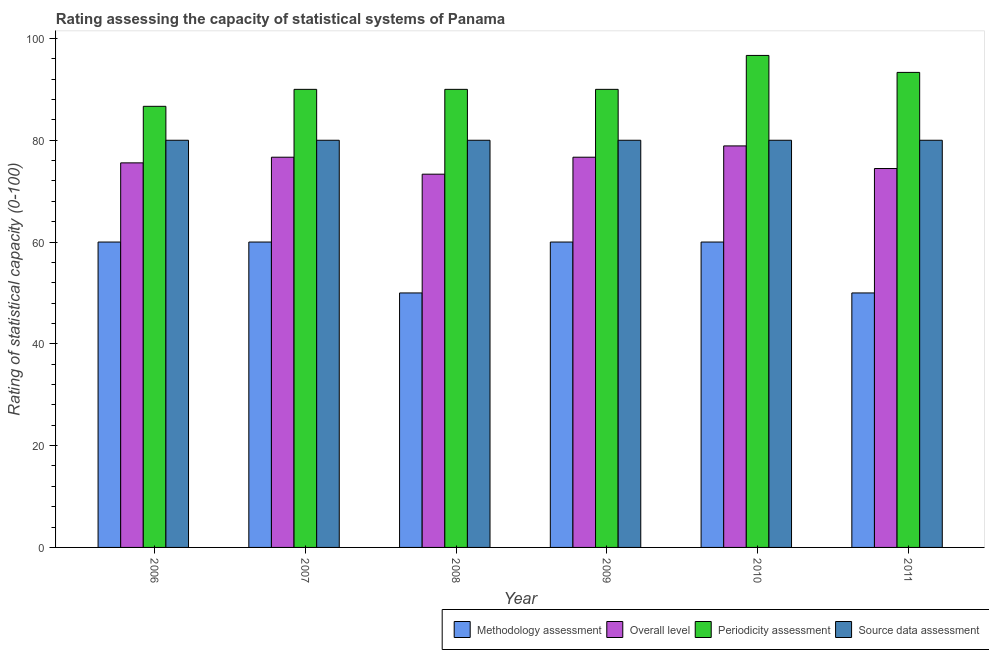How many different coloured bars are there?
Provide a short and direct response. 4. Are the number of bars per tick equal to the number of legend labels?
Your answer should be compact. Yes. Are the number of bars on each tick of the X-axis equal?
Keep it short and to the point. Yes. How many bars are there on the 4th tick from the left?
Your response must be concise. 4. What is the overall level rating in 2008?
Offer a terse response. 73.33. Across all years, what is the maximum methodology assessment rating?
Make the answer very short. 60. Across all years, what is the minimum source data assessment rating?
Your response must be concise. 80. In which year was the source data assessment rating maximum?
Your answer should be compact. 2006. In which year was the methodology assessment rating minimum?
Ensure brevity in your answer.  2008. What is the total periodicity assessment rating in the graph?
Keep it short and to the point. 546.67. What is the difference between the methodology assessment rating in 2006 and that in 2007?
Your answer should be compact. 0. What is the difference between the overall level rating in 2009 and the methodology assessment rating in 2007?
Keep it short and to the point. 0. What is the average overall level rating per year?
Ensure brevity in your answer.  75.93. In the year 2009, what is the difference between the periodicity assessment rating and methodology assessment rating?
Give a very brief answer. 0. In how many years, is the methodology assessment rating greater than 56?
Your response must be concise. 4. What is the ratio of the periodicity assessment rating in 2008 to that in 2011?
Ensure brevity in your answer.  0.96. Is the difference between the periodicity assessment rating in 2009 and 2010 greater than the difference between the source data assessment rating in 2009 and 2010?
Give a very brief answer. No. What is the difference between the highest and the second highest overall level rating?
Keep it short and to the point. 2.22. In how many years, is the periodicity assessment rating greater than the average periodicity assessment rating taken over all years?
Ensure brevity in your answer.  2. What does the 4th bar from the left in 2007 represents?
Your response must be concise. Source data assessment. What does the 2nd bar from the right in 2007 represents?
Provide a succinct answer. Periodicity assessment. How many bars are there?
Ensure brevity in your answer.  24. Are all the bars in the graph horizontal?
Make the answer very short. No. How many years are there in the graph?
Provide a short and direct response. 6. What is the difference between two consecutive major ticks on the Y-axis?
Ensure brevity in your answer.  20. Does the graph contain any zero values?
Your answer should be very brief. No. Does the graph contain grids?
Make the answer very short. No. How many legend labels are there?
Ensure brevity in your answer.  4. What is the title of the graph?
Your answer should be very brief. Rating assessing the capacity of statistical systems of Panama. What is the label or title of the Y-axis?
Ensure brevity in your answer.  Rating of statistical capacity (0-100). What is the Rating of statistical capacity (0-100) in Methodology assessment in 2006?
Ensure brevity in your answer.  60. What is the Rating of statistical capacity (0-100) in Overall level in 2006?
Your answer should be compact. 75.56. What is the Rating of statistical capacity (0-100) of Periodicity assessment in 2006?
Ensure brevity in your answer.  86.67. What is the Rating of statistical capacity (0-100) of Overall level in 2007?
Provide a succinct answer. 76.67. What is the Rating of statistical capacity (0-100) of Methodology assessment in 2008?
Ensure brevity in your answer.  50. What is the Rating of statistical capacity (0-100) of Overall level in 2008?
Ensure brevity in your answer.  73.33. What is the Rating of statistical capacity (0-100) in Periodicity assessment in 2008?
Make the answer very short. 90. What is the Rating of statistical capacity (0-100) of Methodology assessment in 2009?
Offer a very short reply. 60. What is the Rating of statistical capacity (0-100) of Overall level in 2009?
Provide a short and direct response. 76.67. What is the Rating of statistical capacity (0-100) of Periodicity assessment in 2009?
Your response must be concise. 90. What is the Rating of statistical capacity (0-100) in Overall level in 2010?
Give a very brief answer. 78.89. What is the Rating of statistical capacity (0-100) of Periodicity assessment in 2010?
Ensure brevity in your answer.  96.67. What is the Rating of statistical capacity (0-100) in Methodology assessment in 2011?
Make the answer very short. 50. What is the Rating of statistical capacity (0-100) of Overall level in 2011?
Offer a very short reply. 74.44. What is the Rating of statistical capacity (0-100) in Periodicity assessment in 2011?
Your answer should be very brief. 93.33. What is the Rating of statistical capacity (0-100) of Source data assessment in 2011?
Your answer should be very brief. 80. Across all years, what is the maximum Rating of statistical capacity (0-100) in Overall level?
Provide a succinct answer. 78.89. Across all years, what is the maximum Rating of statistical capacity (0-100) in Periodicity assessment?
Your answer should be very brief. 96.67. Across all years, what is the minimum Rating of statistical capacity (0-100) of Methodology assessment?
Provide a succinct answer. 50. Across all years, what is the minimum Rating of statistical capacity (0-100) of Overall level?
Offer a very short reply. 73.33. Across all years, what is the minimum Rating of statistical capacity (0-100) of Periodicity assessment?
Your answer should be compact. 86.67. Across all years, what is the minimum Rating of statistical capacity (0-100) in Source data assessment?
Provide a succinct answer. 80. What is the total Rating of statistical capacity (0-100) of Methodology assessment in the graph?
Your response must be concise. 340. What is the total Rating of statistical capacity (0-100) of Overall level in the graph?
Offer a terse response. 455.56. What is the total Rating of statistical capacity (0-100) of Periodicity assessment in the graph?
Offer a very short reply. 546.67. What is the total Rating of statistical capacity (0-100) of Source data assessment in the graph?
Your answer should be compact. 480. What is the difference between the Rating of statistical capacity (0-100) in Methodology assessment in 2006 and that in 2007?
Keep it short and to the point. 0. What is the difference between the Rating of statistical capacity (0-100) of Overall level in 2006 and that in 2007?
Provide a succinct answer. -1.11. What is the difference between the Rating of statistical capacity (0-100) in Periodicity assessment in 2006 and that in 2007?
Provide a succinct answer. -3.33. What is the difference between the Rating of statistical capacity (0-100) in Source data assessment in 2006 and that in 2007?
Keep it short and to the point. 0. What is the difference between the Rating of statistical capacity (0-100) in Methodology assessment in 2006 and that in 2008?
Give a very brief answer. 10. What is the difference between the Rating of statistical capacity (0-100) in Overall level in 2006 and that in 2008?
Provide a short and direct response. 2.22. What is the difference between the Rating of statistical capacity (0-100) in Periodicity assessment in 2006 and that in 2008?
Offer a very short reply. -3.33. What is the difference between the Rating of statistical capacity (0-100) in Methodology assessment in 2006 and that in 2009?
Provide a short and direct response. 0. What is the difference between the Rating of statistical capacity (0-100) in Overall level in 2006 and that in 2009?
Your response must be concise. -1.11. What is the difference between the Rating of statistical capacity (0-100) of Periodicity assessment in 2006 and that in 2009?
Keep it short and to the point. -3.33. What is the difference between the Rating of statistical capacity (0-100) in Methodology assessment in 2006 and that in 2010?
Ensure brevity in your answer.  0. What is the difference between the Rating of statistical capacity (0-100) in Overall level in 2006 and that in 2010?
Make the answer very short. -3.33. What is the difference between the Rating of statistical capacity (0-100) in Source data assessment in 2006 and that in 2010?
Provide a short and direct response. 0. What is the difference between the Rating of statistical capacity (0-100) of Overall level in 2006 and that in 2011?
Give a very brief answer. 1.11. What is the difference between the Rating of statistical capacity (0-100) of Periodicity assessment in 2006 and that in 2011?
Provide a short and direct response. -6.67. What is the difference between the Rating of statistical capacity (0-100) in Source data assessment in 2006 and that in 2011?
Offer a terse response. 0. What is the difference between the Rating of statistical capacity (0-100) of Periodicity assessment in 2007 and that in 2008?
Provide a succinct answer. 0. What is the difference between the Rating of statistical capacity (0-100) of Overall level in 2007 and that in 2009?
Offer a terse response. 0. What is the difference between the Rating of statistical capacity (0-100) in Methodology assessment in 2007 and that in 2010?
Offer a very short reply. 0. What is the difference between the Rating of statistical capacity (0-100) of Overall level in 2007 and that in 2010?
Your answer should be compact. -2.22. What is the difference between the Rating of statistical capacity (0-100) in Periodicity assessment in 2007 and that in 2010?
Keep it short and to the point. -6.67. What is the difference between the Rating of statistical capacity (0-100) of Overall level in 2007 and that in 2011?
Your answer should be very brief. 2.22. What is the difference between the Rating of statistical capacity (0-100) in Periodicity assessment in 2007 and that in 2011?
Offer a very short reply. -3.33. What is the difference between the Rating of statistical capacity (0-100) in Source data assessment in 2007 and that in 2011?
Provide a succinct answer. 0. What is the difference between the Rating of statistical capacity (0-100) of Methodology assessment in 2008 and that in 2009?
Your response must be concise. -10. What is the difference between the Rating of statistical capacity (0-100) of Periodicity assessment in 2008 and that in 2009?
Ensure brevity in your answer.  0. What is the difference between the Rating of statistical capacity (0-100) of Methodology assessment in 2008 and that in 2010?
Your answer should be compact. -10. What is the difference between the Rating of statistical capacity (0-100) in Overall level in 2008 and that in 2010?
Ensure brevity in your answer.  -5.56. What is the difference between the Rating of statistical capacity (0-100) in Periodicity assessment in 2008 and that in 2010?
Your answer should be very brief. -6.67. What is the difference between the Rating of statistical capacity (0-100) in Source data assessment in 2008 and that in 2010?
Keep it short and to the point. 0. What is the difference between the Rating of statistical capacity (0-100) in Methodology assessment in 2008 and that in 2011?
Your answer should be very brief. 0. What is the difference between the Rating of statistical capacity (0-100) of Overall level in 2008 and that in 2011?
Give a very brief answer. -1.11. What is the difference between the Rating of statistical capacity (0-100) of Periodicity assessment in 2008 and that in 2011?
Provide a short and direct response. -3.33. What is the difference between the Rating of statistical capacity (0-100) in Methodology assessment in 2009 and that in 2010?
Make the answer very short. 0. What is the difference between the Rating of statistical capacity (0-100) in Overall level in 2009 and that in 2010?
Ensure brevity in your answer.  -2.22. What is the difference between the Rating of statistical capacity (0-100) of Periodicity assessment in 2009 and that in 2010?
Give a very brief answer. -6.67. What is the difference between the Rating of statistical capacity (0-100) in Source data assessment in 2009 and that in 2010?
Offer a terse response. 0. What is the difference between the Rating of statistical capacity (0-100) of Overall level in 2009 and that in 2011?
Your answer should be very brief. 2.22. What is the difference between the Rating of statistical capacity (0-100) of Source data assessment in 2009 and that in 2011?
Your answer should be compact. 0. What is the difference between the Rating of statistical capacity (0-100) of Methodology assessment in 2010 and that in 2011?
Give a very brief answer. 10. What is the difference between the Rating of statistical capacity (0-100) of Overall level in 2010 and that in 2011?
Offer a terse response. 4.44. What is the difference between the Rating of statistical capacity (0-100) in Methodology assessment in 2006 and the Rating of statistical capacity (0-100) in Overall level in 2007?
Your answer should be very brief. -16.67. What is the difference between the Rating of statistical capacity (0-100) in Methodology assessment in 2006 and the Rating of statistical capacity (0-100) in Periodicity assessment in 2007?
Offer a terse response. -30. What is the difference between the Rating of statistical capacity (0-100) in Methodology assessment in 2006 and the Rating of statistical capacity (0-100) in Source data assessment in 2007?
Offer a very short reply. -20. What is the difference between the Rating of statistical capacity (0-100) of Overall level in 2006 and the Rating of statistical capacity (0-100) of Periodicity assessment in 2007?
Provide a short and direct response. -14.44. What is the difference between the Rating of statistical capacity (0-100) in Overall level in 2006 and the Rating of statistical capacity (0-100) in Source data assessment in 2007?
Offer a very short reply. -4.44. What is the difference between the Rating of statistical capacity (0-100) in Methodology assessment in 2006 and the Rating of statistical capacity (0-100) in Overall level in 2008?
Your answer should be compact. -13.33. What is the difference between the Rating of statistical capacity (0-100) in Methodology assessment in 2006 and the Rating of statistical capacity (0-100) in Periodicity assessment in 2008?
Make the answer very short. -30. What is the difference between the Rating of statistical capacity (0-100) of Methodology assessment in 2006 and the Rating of statistical capacity (0-100) of Source data assessment in 2008?
Keep it short and to the point. -20. What is the difference between the Rating of statistical capacity (0-100) in Overall level in 2006 and the Rating of statistical capacity (0-100) in Periodicity assessment in 2008?
Your answer should be compact. -14.44. What is the difference between the Rating of statistical capacity (0-100) of Overall level in 2006 and the Rating of statistical capacity (0-100) of Source data assessment in 2008?
Your response must be concise. -4.44. What is the difference between the Rating of statistical capacity (0-100) in Periodicity assessment in 2006 and the Rating of statistical capacity (0-100) in Source data assessment in 2008?
Offer a terse response. 6.67. What is the difference between the Rating of statistical capacity (0-100) in Methodology assessment in 2006 and the Rating of statistical capacity (0-100) in Overall level in 2009?
Make the answer very short. -16.67. What is the difference between the Rating of statistical capacity (0-100) in Methodology assessment in 2006 and the Rating of statistical capacity (0-100) in Source data assessment in 2009?
Provide a succinct answer. -20. What is the difference between the Rating of statistical capacity (0-100) of Overall level in 2006 and the Rating of statistical capacity (0-100) of Periodicity assessment in 2009?
Ensure brevity in your answer.  -14.44. What is the difference between the Rating of statistical capacity (0-100) of Overall level in 2006 and the Rating of statistical capacity (0-100) of Source data assessment in 2009?
Your answer should be very brief. -4.44. What is the difference between the Rating of statistical capacity (0-100) of Periodicity assessment in 2006 and the Rating of statistical capacity (0-100) of Source data assessment in 2009?
Provide a succinct answer. 6.67. What is the difference between the Rating of statistical capacity (0-100) in Methodology assessment in 2006 and the Rating of statistical capacity (0-100) in Overall level in 2010?
Your response must be concise. -18.89. What is the difference between the Rating of statistical capacity (0-100) in Methodology assessment in 2006 and the Rating of statistical capacity (0-100) in Periodicity assessment in 2010?
Provide a succinct answer. -36.67. What is the difference between the Rating of statistical capacity (0-100) of Methodology assessment in 2006 and the Rating of statistical capacity (0-100) of Source data assessment in 2010?
Provide a succinct answer. -20. What is the difference between the Rating of statistical capacity (0-100) in Overall level in 2006 and the Rating of statistical capacity (0-100) in Periodicity assessment in 2010?
Ensure brevity in your answer.  -21.11. What is the difference between the Rating of statistical capacity (0-100) of Overall level in 2006 and the Rating of statistical capacity (0-100) of Source data assessment in 2010?
Provide a short and direct response. -4.44. What is the difference between the Rating of statistical capacity (0-100) of Methodology assessment in 2006 and the Rating of statistical capacity (0-100) of Overall level in 2011?
Give a very brief answer. -14.44. What is the difference between the Rating of statistical capacity (0-100) of Methodology assessment in 2006 and the Rating of statistical capacity (0-100) of Periodicity assessment in 2011?
Offer a terse response. -33.33. What is the difference between the Rating of statistical capacity (0-100) in Methodology assessment in 2006 and the Rating of statistical capacity (0-100) in Source data assessment in 2011?
Provide a succinct answer. -20. What is the difference between the Rating of statistical capacity (0-100) in Overall level in 2006 and the Rating of statistical capacity (0-100) in Periodicity assessment in 2011?
Offer a very short reply. -17.78. What is the difference between the Rating of statistical capacity (0-100) in Overall level in 2006 and the Rating of statistical capacity (0-100) in Source data assessment in 2011?
Your answer should be compact. -4.44. What is the difference between the Rating of statistical capacity (0-100) in Methodology assessment in 2007 and the Rating of statistical capacity (0-100) in Overall level in 2008?
Ensure brevity in your answer.  -13.33. What is the difference between the Rating of statistical capacity (0-100) in Methodology assessment in 2007 and the Rating of statistical capacity (0-100) in Periodicity assessment in 2008?
Provide a short and direct response. -30. What is the difference between the Rating of statistical capacity (0-100) of Methodology assessment in 2007 and the Rating of statistical capacity (0-100) of Source data assessment in 2008?
Your answer should be very brief. -20. What is the difference between the Rating of statistical capacity (0-100) in Overall level in 2007 and the Rating of statistical capacity (0-100) in Periodicity assessment in 2008?
Your answer should be compact. -13.33. What is the difference between the Rating of statistical capacity (0-100) of Overall level in 2007 and the Rating of statistical capacity (0-100) of Source data assessment in 2008?
Keep it short and to the point. -3.33. What is the difference between the Rating of statistical capacity (0-100) in Methodology assessment in 2007 and the Rating of statistical capacity (0-100) in Overall level in 2009?
Offer a very short reply. -16.67. What is the difference between the Rating of statistical capacity (0-100) of Methodology assessment in 2007 and the Rating of statistical capacity (0-100) of Source data assessment in 2009?
Give a very brief answer. -20. What is the difference between the Rating of statistical capacity (0-100) in Overall level in 2007 and the Rating of statistical capacity (0-100) in Periodicity assessment in 2009?
Offer a very short reply. -13.33. What is the difference between the Rating of statistical capacity (0-100) in Overall level in 2007 and the Rating of statistical capacity (0-100) in Source data assessment in 2009?
Ensure brevity in your answer.  -3.33. What is the difference between the Rating of statistical capacity (0-100) in Periodicity assessment in 2007 and the Rating of statistical capacity (0-100) in Source data assessment in 2009?
Offer a terse response. 10. What is the difference between the Rating of statistical capacity (0-100) of Methodology assessment in 2007 and the Rating of statistical capacity (0-100) of Overall level in 2010?
Make the answer very short. -18.89. What is the difference between the Rating of statistical capacity (0-100) of Methodology assessment in 2007 and the Rating of statistical capacity (0-100) of Periodicity assessment in 2010?
Give a very brief answer. -36.67. What is the difference between the Rating of statistical capacity (0-100) in Overall level in 2007 and the Rating of statistical capacity (0-100) in Periodicity assessment in 2010?
Ensure brevity in your answer.  -20. What is the difference between the Rating of statistical capacity (0-100) of Methodology assessment in 2007 and the Rating of statistical capacity (0-100) of Overall level in 2011?
Ensure brevity in your answer.  -14.44. What is the difference between the Rating of statistical capacity (0-100) in Methodology assessment in 2007 and the Rating of statistical capacity (0-100) in Periodicity assessment in 2011?
Provide a short and direct response. -33.33. What is the difference between the Rating of statistical capacity (0-100) in Overall level in 2007 and the Rating of statistical capacity (0-100) in Periodicity assessment in 2011?
Offer a terse response. -16.67. What is the difference between the Rating of statistical capacity (0-100) of Periodicity assessment in 2007 and the Rating of statistical capacity (0-100) of Source data assessment in 2011?
Your response must be concise. 10. What is the difference between the Rating of statistical capacity (0-100) in Methodology assessment in 2008 and the Rating of statistical capacity (0-100) in Overall level in 2009?
Offer a very short reply. -26.67. What is the difference between the Rating of statistical capacity (0-100) in Overall level in 2008 and the Rating of statistical capacity (0-100) in Periodicity assessment in 2009?
Offer a terse response. -16.67. What is the difference between the Rating of statistical capacity (0-100) in Overall level in 2008 and the Rating of statistical capacity (0-100) in Source data assessment in 2009?
Your answer should be compact. -6.67. What is the difference between the Rating of statistical capacity (0-100) of Methodology assessment in 2008 and the Rating of statistical capacity (0-100) of Overall level in 2010?
Make the answer very short. -28.89. What is the difference between the Rating of statistical capacity (0-100) in Methodology assessment in 2008 and the Rating of statistical capacity (0-100) in Periodicity assessment in 2010?
Your answer should be compact. -46.67. What is the difference between the Rating of statistical capacity (0-100) in Methodology assessment in 2008 and the Rating of statistical capacity (0-100) in Source data assessment in 2010?
Make the answer very short. -30. What is the difference between the Rating of statistical capacity (0-100) of Overall level in 2008 and the Rating of statistical capacity (0-100) of Periodicity assessment in 2010?
Make the answer very short. -23.33. What is the difference between the Rating of statistical capacity (0-100) in Overall level in 2008 and the Rating of statistical capacity (0-100) in Source data assessment in 2010?
Your answer should be very brief. -6.67. What is the difference between the Rating of statistical capacity (0-100) in Periodicity assessment in 2008 and the Rating of statistical capacity (0-100) in Source data assessment in 2010?
Make the answer very short. 10. What is the difference between the Rating of statistical capacity (0-100) of Methodology assessment in 2008 and the Rating of statistical capacity (0-100) of Overall level in 2011?
Ensure brevity in your answer.  -24.44. What is the difference between the Rating of statistical capacity (0-100) in Methodology assessment in 2008 and the Rating of statistical capacity (0-100) in Periodicity assessment in 2011?
Your answer should be compact. -43.33. What is the difference between the Rating of statistical capacity (0-100) in Overall level in 2008 and the Rating of statistical capacity (0-100) in Source data assessment in 2011?
Give a very brief answer. -6.67. What is the difference between the Rating of statistical capacity (0-100) in Periodicity assessment in 2008 and the Rating of statistical capacity (0-100) in Source data assessment in 2011?
Make the answer very short. 10. What is the difference between the Rating of statistical capacity (0-100) of Methodology assessment in 2009 and the Rating of statistical capacity (0-100) of Overall level in 2010?
Your answer should be very brief. -18.89. What is the difference between the Rating of statistical capacity (0-100) of Methodology assessment in 2009 and the Rating of statistical capacity (0-100) of Periodicity assessment in 2010?
Provide a short and direct response. -36.67. What is the difference between the Rating of statistical capacity (0-100) of Methodology assessment in 2009 and the Rating of statistical capacity (0-100) of Source data assessment in 2010?
Your answer should be very brief. -20. What is the difference between the Rating of statistical capacity (0-100) in Periodicity assessment in 2009 and the Rating of statistical capacity (0-100) in Source data assessment in 2010?
Your answer should be very brief. 10. What is the difference between the Rating of statistical capacity (0-100) in Methodology assessment in 2009 and the Rating of statistical capacity (0-100) in Overall level in 2011?
Offer a very short reply. -14.44. What is the difference between the Rating of statistical capacity (0-100) of Methodology assessment in 2009 and the Rating of statistical capacity (0-100) of Periodicity assessment in 2011?
Offer a very short reply. -33.33. What is the difference between the Rating of statistical capacity (0-100) in Methodology assessment in 2009 and the Rating of statistical capacity (0-100) in Source data assessment in 2011?
Ensure brevity in your answer.  -20. What is the difference between the Rating of statistical capacity (0-100) of Overall level in 2009 and the Rating of statistical capacity (0-100) of Periodicity assessment in 2011?
Your response must be concise. -16.67. What is the difference between the Rating of statistical capacity (0-100) of Overall level in 2009 and the Rating of statistical capacity (0-100) of Source data assessment in 2011?
Offer a terse response. -3.33. What is the difference between the Rating of statistical capacity (0-100) in Methodology assessment in 2010 and the Rating of statistical capacity (0-100) in Overall level in 2011?
Your answer should be very brief. -14.44. What is the difference between the Rating of statistical capacity (0-100) in Methodology assessment in 2010 and the Rating of statistical capacity (0-100) in Periodicity assessment in 2011?
Provide a short and direct response. -33.33. What is the difference between the Rating of statistical capacity (0-100) in Overall level in 2010 and the Rating of statistical capacity (0-100) in Periodicity assessment in 2011?
Offer a very short reply. -14.44. What is the difference between the Rating of statistical capacity (0-100) in Overall level in 2010 and the Rating of statistical capacity (0-100) in Source data assessment in 2011?
Make the answer very short. -1.11. What is the difference between the Rating of statistical capacity (0-100) of Periodicity assessment in 2010 and the Rating of statistical capacity (0-100) of Source data assessment in 2011?
Ensure brevity in your answer.  16.67. What is the average Rating of statistical capacity (0-100) of Methodology assessment per year?
Keep it short and to the point. 56.67. What is the average Rating of statistical capacity (0-100) of Overall level per year?
Keep it short and to the point. 75.93. What is the average Rating of statistical capacity (0-100) in Periodicity assessment per year?
Keep it short and to the point. 91.11. What is the average Rating of statistical capacity (0-100) in Source data assessment per year?
Your answer should be compact. 80. In the year 2006, what is the difference between the Rating of statistical capacity (0-100) of Methodology assessment and Rating of statistical capacity (0-100) of Overall level?
Make the answer very short. -15.56. In the year 2006, what is the difference between the Rating of statistical capacity (0-100) in Methodology assessment and Rating of statistical capacity (0-100) in Periodicity assessment?
Your answer should be compact. -26.67. In the year 2006, what is the difference between the Rating of statistical capacity (0-100) of Methodology assessment and Rating of statistical capacity (0-100) of Source data assessment?
Make the answer very short. -20. In the year 2006, what is the difference between the Rating of statistical capacity (0-100) of Overall level and Rating of statistical capacity (0-100) of Periodicity assessment?
Ensure brevity in your answer.  -11.11. In the year 2006, what is the difference between the Rating of statistical capacity (0-100) of Overall level and Rating of statistical capacity (0-100) of Source data assessment?
Keep it short and to the point. -4.44. In the year 2006, what is the difference between the Rating of statistical capacity (0-100) of Periodicity assessment and Rating of statistical capacity (0-100) of Source data assessment?
Make the answer very short. 6.67. In the year 2007, what is the difference between the Rating of statistical capacity (0-100) of Methodology assessment and Rating of statistical capacity (0-100) of Overall level?
Offer a very short reply. -16.67. In the year 2007, what is the difference between the Rating of statistical capacity (0-100) of Overall level and Rating of statistical capacity (0-100) of Periodicity assessment?
Provide a short and direct response. -13.33. In the year 2007, what is the difference between the Rating of statistical capacity (0-100) of Periodicity assessment and Rating of statistical capacity (0-100) of Source data assessment?
Your response must be concise. 10. In the year 2008, what is the difference between the Rating of statistical capacity (0-100) of Methodology assessment and Rating of statistical capacity (0-100) of Overall level?
Make the answer very short. -23.33. In the year 2008, what is the difference between the Rating of statistical capacity (0-100) in Overall level and Rating of statistical capacity (0-100) in Periodicity assessment?
Your response must be concise. -16.67. In the year 2008, what is the difference between the Rating of statistical capacity (0-100) of Overall level and Rating of statistical capacity (0-100) of Source data assessment?
Provide a short and direct response. -6.67. In the year 2008, what is the difference between the Rating of statistical capacity (0-100) in Periodicity assessment and Rating of statistical capacity (0-100) in Source data assessment?
Keep it short and to the point. 10. In the year 2009, what is the difference between the Rating of statistical capacity (0-100) in Methodology assessment and Rating of statistical capacity (0-100) in Overall level?
Give a very brief answer. -16.67. In the year 2009, what is the difference between the Rating of statistical capacity (0-100) of Methodology assessment and Rating of statistical capacity (0-100) of Periodicity assessment?
Your answer should be very brief. -30. In the year 2009, what is the difference between the Rating of statistical capacity (0-100) in Overall level and Rating of statistical capacity (0-100) in Periodicity assessment?
Keep it short and to the point. -13.33. In the year 2009, what is the difference between the Rating of statistical capacity (0-100) of Overall level and Rating of statistical capacity (0-100) of Source data assessment?
Provide a succinct answer. -3.33. In the year 2009, what is the difference between the Rating of statistical capacity (0-100) in Periodicity assessment and Rating of statistical capacity (0-100) in Source data assessment?
Ensure brevity in your answer.  10. In the year 2010, what is the difference between the Rating of statistical capacity (0-100) of Methodology assessment and Rating of statistical capacity (0-100) of Overall level?
Ensure brevity in your answer.  -18.89. In the year 2010, what is the difference between the Rating of statistical capacity (0-100) in Methodology assessment and Rating of statistical capacity (0-100) in Periodicity assessment?
Offer a very short reply. -36.67. In the year 2010, what is the difference between the Rating of statistical capacity (0-100) in Overall level and Rating of statistical capacity (0-100) in Periodicity assessment?
Your answer should be compact. -17.78. In the year 2010, what is the difference between the Rating of statistical capacity (0-100) in Overall level and Rating of statistical capacity (0-100) in Source data assessment?
Make the answer very short. -1.11. In the year 2010, what is the difference between the Rating of statistical capacity (0-100) of Periodicity assessment and Rating of statistical capacity (0-100) of Source data assessment?
Your answer should be compact. 16.67. In the year 2011, what is the difference between the Rating of statistical capacity (0-100) of Methodology assessment and Rating of statistical capacity (0-100) of Overall level?
Offer a terse response. -24.44. In the year 2011, what is the difference between the Rating of statistical capacity (0-100) of Methodology assessment and Rating of statistical capacity (0-100) of Periodicity assessment?
Keep it short and to the point. -43.33. In the year 2011, what is the difference between the Rating of statistical capacity (0-100) of Overall level and Rating of statistical capacity (0-100) of Periodicity assessment?
Provide a succinct answer. -18.89. In the year 2011, what is the difference between the Rating of statistical capacity (0-100) in Overall level and Rating of statistical capacity (0-100) in Source data assessment?
Keep it short and to the point. -5.56. In the year 2011, what is the difference between the Rating of statistical capacity (0-100) of Periodicity assessment and Rating of statistical capacity (0-100) of Source data assessment?
Provide a short and direct response. 13.33. What is the ratio of the Rating of statistical capacity (0-100) in Methodology assessment in 2006 to that in 2007?
Offer a terse response. 1. What is the ratio of the Rating of statistical capacity (0-100) of Overall level in 2006 to that in 2007?
Make the answer very short. 0.99. What is the ratio of the Rating of statistical capacity (0-100) in Overall level in 2006 to that in 2008?
Provide a short and direct response. 1.03. What is the ratio of the Rating of statistical capacity (0-100) of Overall level in 2006 to that in 2009?
Offer a very short reply. 0.99. What is the ratio of the Rating of statistical capacity (0-100) of Source data assessment in 2006 to that in 2009?
Ensure brevity in your answer.  1. What is the ratio of the Rating of statistical capacity (0-100) of Methodology assessment in 2006 to that in 2010?
Provide a succinct answer. 1. What is the ratio of the Rating of statistical capacity (0-100) in Overall level in 2006 to that in 2010?
Ensure brevity in your answer.  0.96. What is the ratio of the Rating of statistical capacity (0-100) of Periodicity assessment in 2006 to that in 2010?
Provide a succinct answer. 0.9. What is the ratio of the Rating of statistical capacity (0-100) in Source data assessment in 2006 to that in 2010?
Your answer should be compact. 1. What is the ratio of the Rating of statistical capacity (0-100) of Overall level in 2006 to that in 2011?
Your answer should be compact. 1.01. What is the ratio of the Rating of statistical capacity (0-100) in Source data assessment in 2006 to that in 2011?
Your answer should be compact. 1. What is the ratio of the Rating of statistical capacity (0-100) in Methodology assessment in 2007 to that in 2008?
Offer a very short reply. 1.2. What is the ratio of the Rating of statistical capacity (0-100) of Overall level in 2007 to that in 2008?
Your response must be concise. 1.05. What is the ratio of the Rating of statistical capacity (0-100) of Periodicity assessment in 2007 to that in 2008?
Make the answer very short. 1. What is the ratio of the Rating of statistical capacity (0-100) in Methodology assessment in 2007 to that in 2009?
Keep it short and to the point. 1. What is the ratio of the Rating of statistical capacity (0-100) in Periodicity assessment in 2007 to that in 2009?
Ensure brevity in your answer.  1. What is the ratio of the Rating of statistical capacity (0-100) in Overall level in 2007 to that in 2010?
Offer a very short reply. 0.97. What is the ratio of the Rating of statistical capacity (0-100) in Periodicity assessment in 2007 to that in 2010?
Give a very brief answer. 0.93. What is the ratio of the Rating of statistical capacity (0-100) in Source data assessment in 2007 to that in 2010?
Provide a succinct answer. 1. What is the ratio of the Rating of statistical capacity (0-100) of Methodology assessment in 2007 to that in 2011?
Your response must be concise. 1.2. What is the ratio of the Rating of statistical capacity (0-100) in Overall level in 2007 to that in 2011?
Your response must be concise. 1.03. What is the ratio of the Rating of statistical capacity (0-100) in Methodology assessment in 2008 to that in 2009?
Provide a short and direct response. 0.83. What is the ratio of the Rating of statistical capacity (0-100) in Overall level in 2008 to that in 2009?
Keep it short and to the point. 0.96. What is the ratio of the Rating of statistical capacity (0-100) of Periodicity assessment in 2008 to that in 2009?
Your answer should be very brief. 1. What is the ratio of the Rating of statistical capacity (0-100) in Methodology assessment in 2008 to that in 2010?
Make the answer very short. 0.83. What is the ratio of the Rating of statistical capacity (0-100) in Overall level in 2008 to that in 2010?
Offer a terse response. 0.93. What is the ratio of the Rating of statistical capacity (0-100) in Overall level in 2008 to that in 2011?
Your answer should be compact. 0.99. What is the ratio of the Rating of statistical capacity (0-100) in Periodicity assessment in 2008 to that in 2011?
Your response must be concise. 0.96. What is the ratio of the Rating of statistical capacity (0-100) in Overall level in 2009 to that in 2010?
Your answer should be very brief. 0.97. What is the ratio of the Rating of statistical capacity (0-100) of Overall level in 2009 to that in 2011?
Provide a short and direct response. 1.03. What is the ratio of the Rating of statistical capacity (0-100) in Periodicity assessment in 2009 to that in 2011?
Offer a very short reply. 0.96. What is the ratio of the Rating of statistical capacity (0-100) in Overall level in 2010 to that in 2011?
Provide a succinct answer. 1.06. What is the ratio of the Rating of statistical capacity (0-100) in Periodicity assessment in 2010 to that in 2011?
Provide a succinct answer. 1.04. What is the difference between the highest and the second highest Rating of statistical capacity (0-100) of Methodology assessment?
Your answer should be compact. 0. What is the difference between the highest and the second highest Rating of statistical capacity (0-100) of Overall level?
Give a very brief answer. 2.22. What is the difference between the highest and the second highest Rating of statistical capacity (0-100) of Periodicity assessment?
Provide a short and direct response. 3.33. What is the difference between the highest and the second highest Rating of statistical capacity (0-100) in Source data assessment?
Make the answer very short. 0. What is the difference between the highest and the lowest Rating of statistical capacity (0-100) in Methodology assessment?
Ensure brevity in your answer.  10. What is the difference between the highest and the lowest Rating of statistical capacity (0-100) of Overall level?
Offer a terse response. 5.56. What is the difference between the highest and the lowest Rating of statistical capacity (0-100) of Periodicity assessment?
Make the answer very short. 10. 